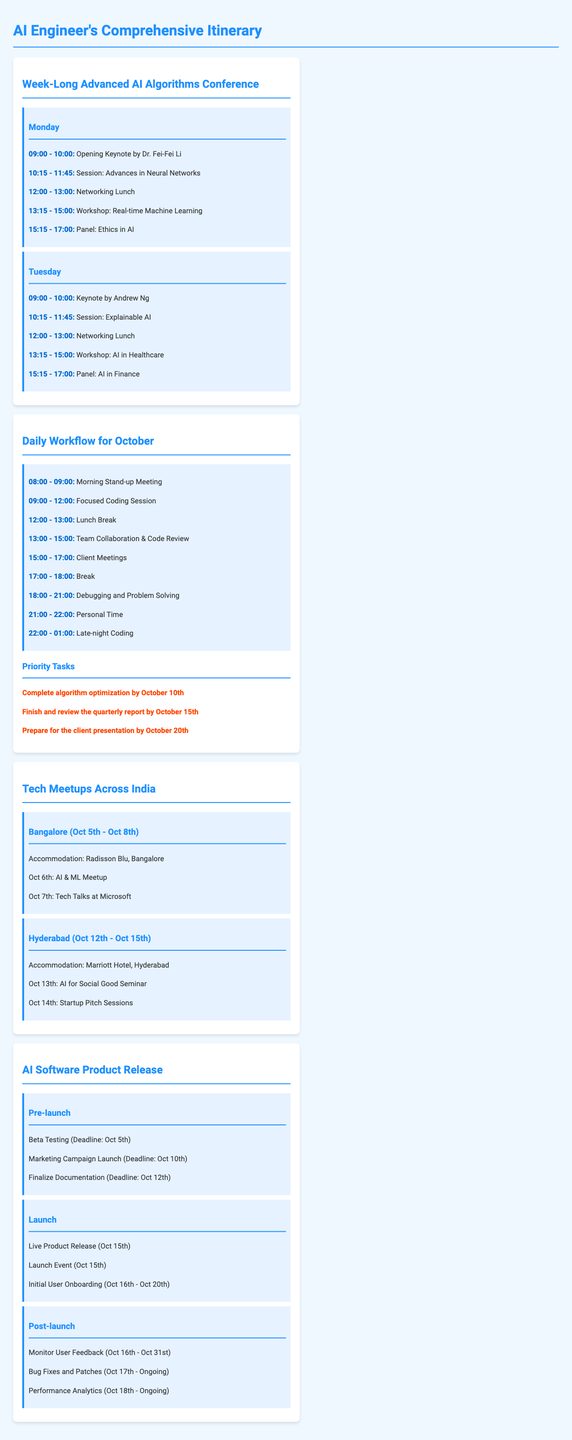What is the date of the keynote by Dr. Fei-Fei Li? The keynote by Dr. Fei-Fei Li is scheduled for the first day of the conference, which is Monday.
Answer: Monday What session occurs after "Advances in Neural Networks"? The session following "Advances in Neural Networks" is titled "Real-time Machine Learning".
Answer: Real-time Machine Learning How long is the debugging session on typical workdays? The debugging session is scheduled from 6:00 PM to 9:00 PM, making it a three-hour session.
Answer: 3 hours What is the accommodation in Bangalore? The accommodation in Bangalore is the Radisson Blu.
Answer: Radisson Blu What is the deadline for completing the algorithm optimization? The deadline for completing the algorithm optimization is October 10th.
Answer: October 10th Which speaker is presenting on Tuesday? On Tuesday, the keynote will be delivered by Andrew Ng.
Answer: Andrew Ng What event is happening on October 13th in Hyderabad? The event on October 13th is the "AI for Social Good Seminar".
Answer: AI for Social Good Seminar During which days is the live product release scheduled? The live product release is scheduled for October 15th.
Answer: October 15th What is the total duration of the AI software's post-launch monitoring tasks? The post-launch monitoring tasks are set from October 16th to October 31st, totaling 16 days.
Answer: 16 days 